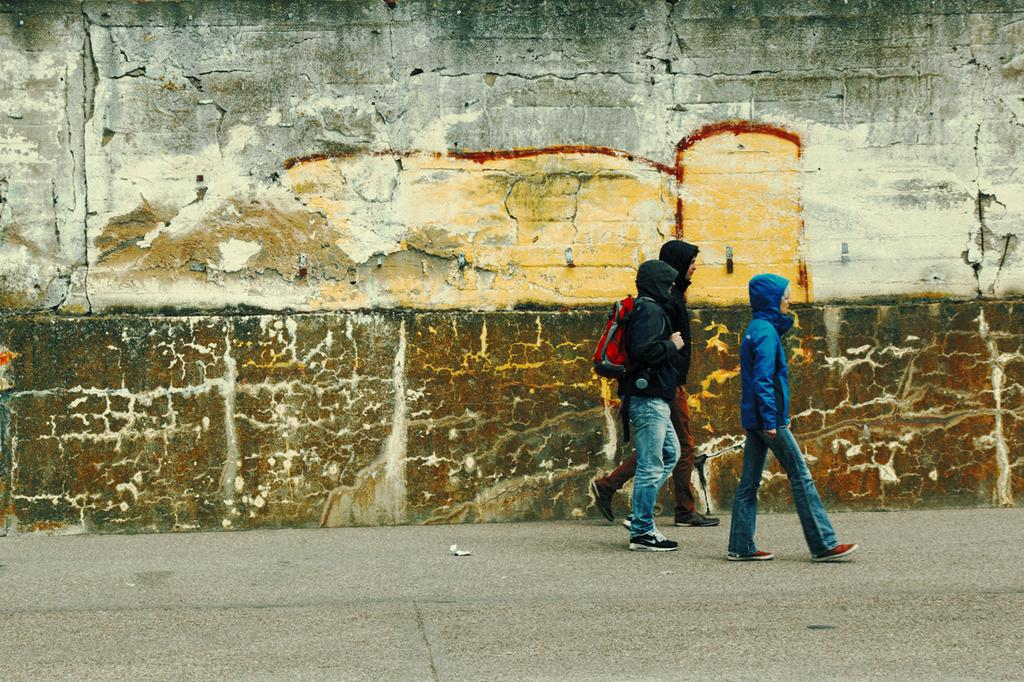What are the people in the image doing? The people in the image are walking in the foreground. What can be seen in the background of the image? There is a wall in the background of the image. How many chickens are sitting on the tree in the image? There is no tree or chickens present in the image. What color is the finger of the person walking in the image? There is no mention of a finger or its color in the image. 